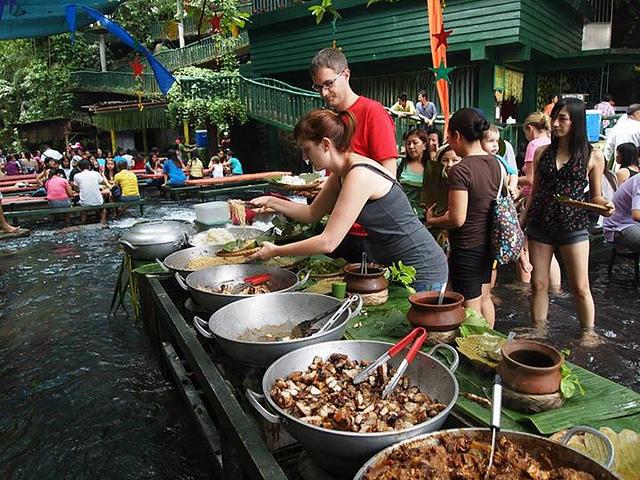What religion are these women?
Concise answer only. Christian. Where is the food?
Give a very brief answer. Pots. Is the place flooded?
Quick response, please. Yes. Where are the tongs?
Quick response, please. Bowls. 